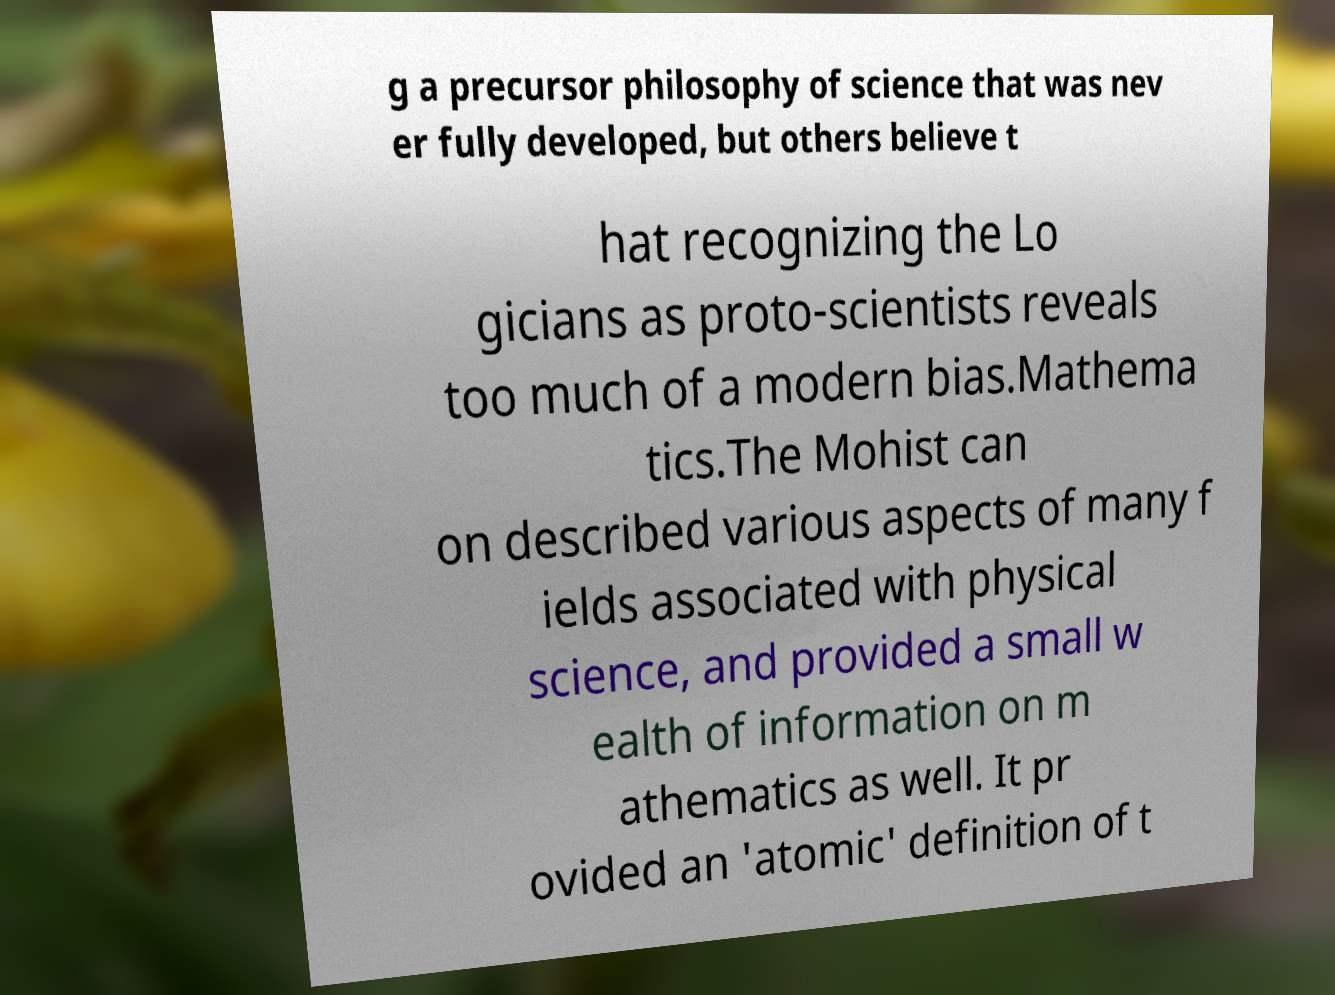Could you extract and type out the text from this image? g a precursor philosophy of science that was nev er fully developed, but others believe t hat recognizing the Lo gicians as proto-scientists reveals too much of a modern bias.Mathema tics.The Mohist can on described various aspects of many f ields associated with physical science, and provided a small w ealth of information on m athematics as well. It pr ovided an 'atomic' definition of t 